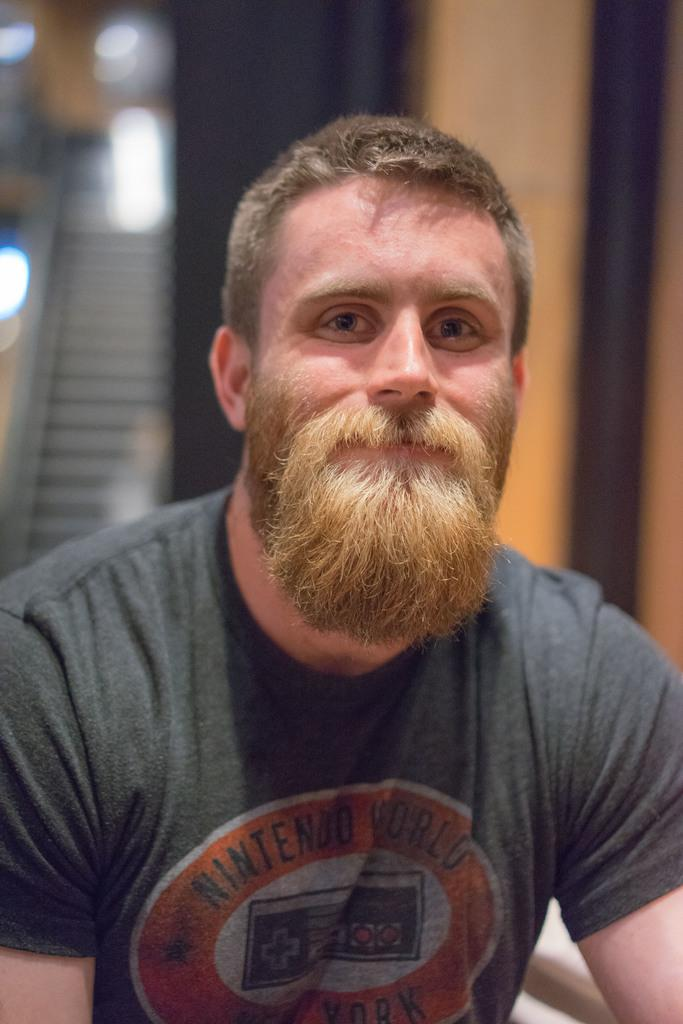Who is present in the image? There is a man in the image. What is the man doing in the image? The man is smiling in the image. What can be seen in the background of the image? There is an escalator and a wall in the background of the image. How many goldfish are swimming near the man in the image? There are no goldfish present in the image. What type of twig is the man holding in the image? There is no twig present in the image. 